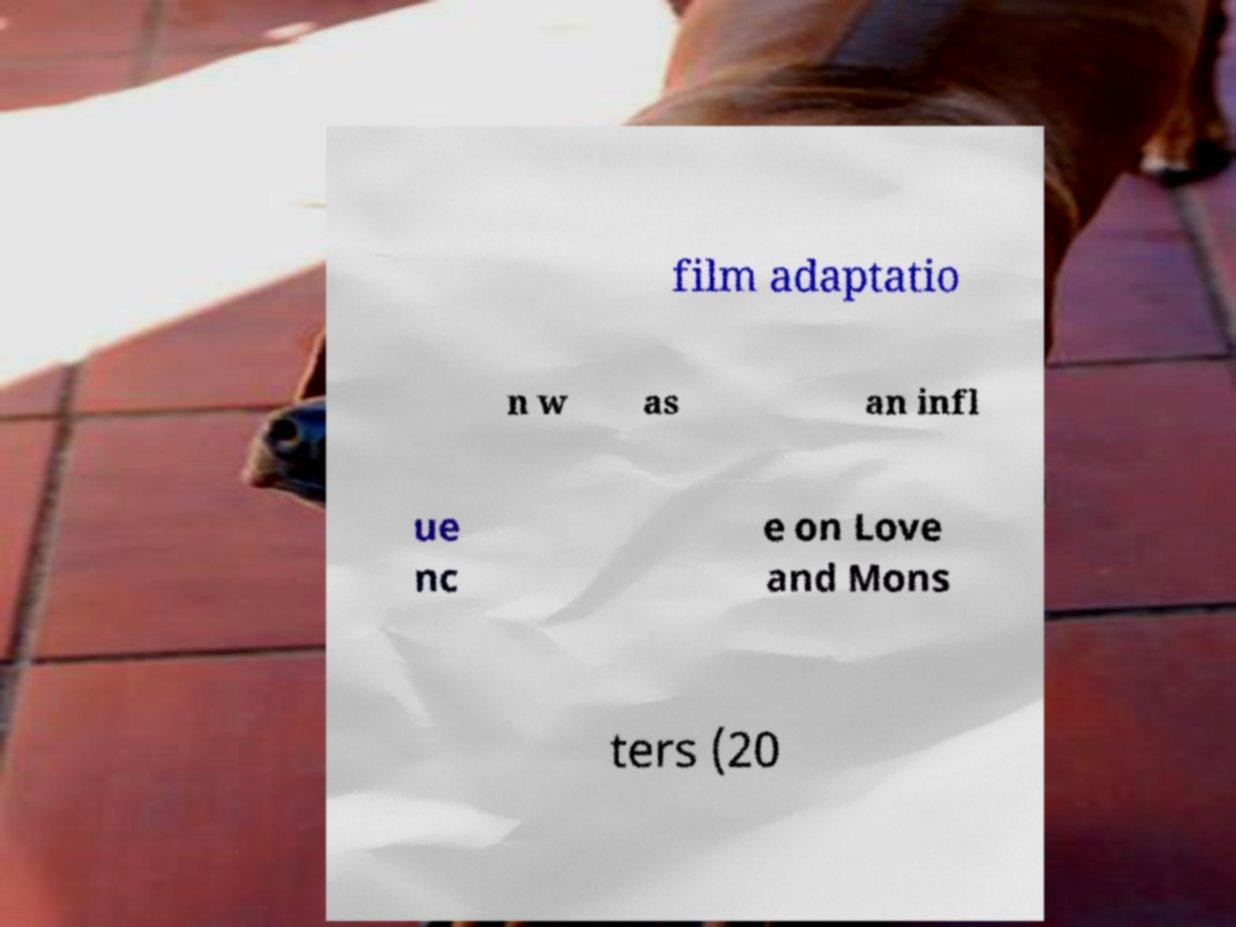Can you accurately transcribe the text from the provided image for me? film adaptatio n w as an infl ue nc e on Love and Mons ters (20 